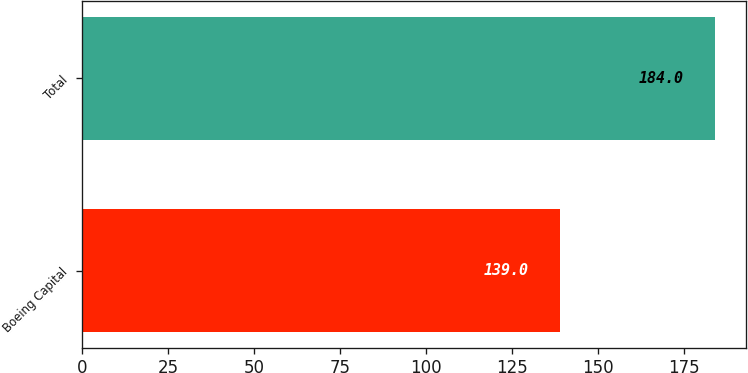Convert chart to OTSL. <chart><loc_0><loc_0><loc_500><loc_500><bar_chart><fcel>Boeing Capital<fcel>Total<nl><fcel>139<fcel>184<nl></chart> 